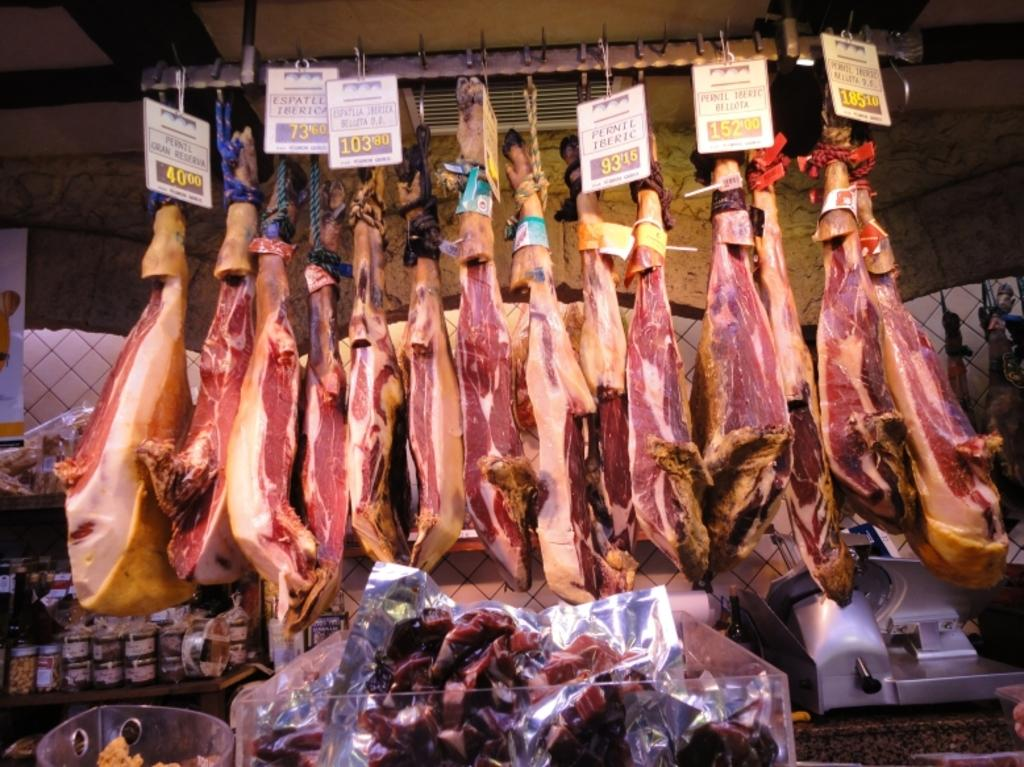What type of food items can be seen in the image? There are food items in packets in the image. Where are the food items located in the image? The food items are in the front of the image. What else can be seen hanging in the image? There is meat hanging in the image. How can one determine the price of the food items? There are price tags in the image. What is present at the back of the image? There is a fence at the back of the image. What type of nut is stored in the jar in the image? There is no jar present in the image, so it is not possible to determine the type of nut stored in it. 